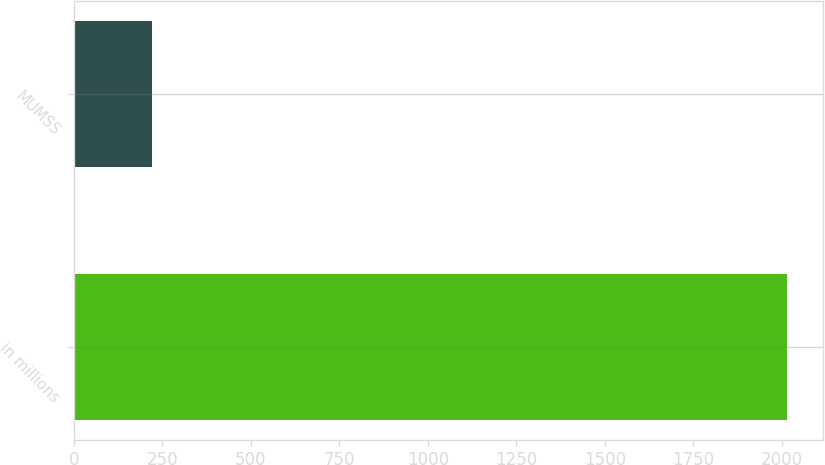Convert chart. <chart><loc_0><loc_0><loc_500><loc_500><bar_chart><fcel>in millions<fcel>MUMSS<nl><fcel>2015<fcel>220<nl></chart> 